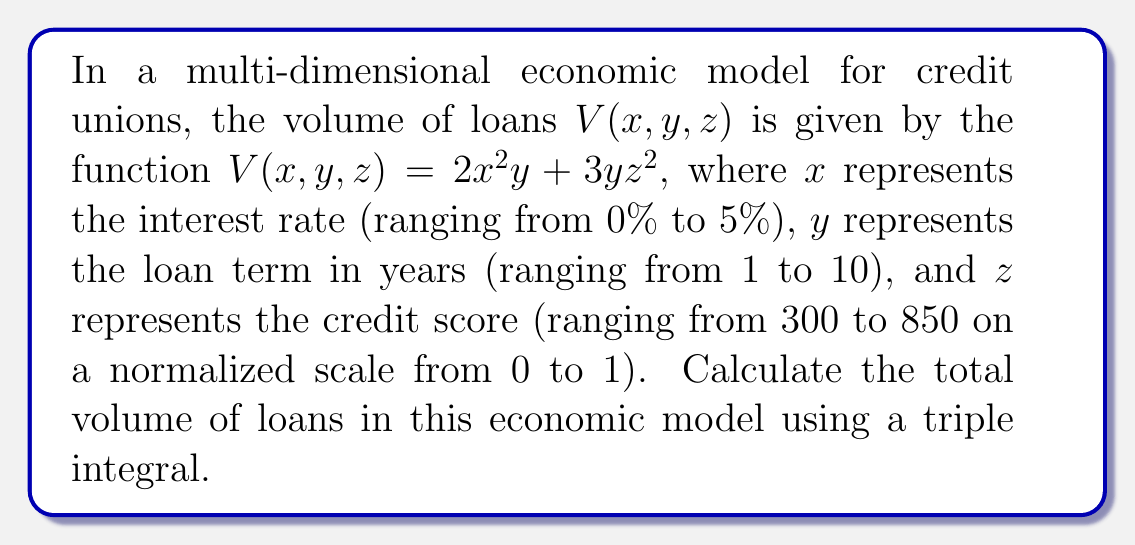Could you help me with this problem? To solve this problem, we need to set up and evaluate a triple integral over the given ranges for each variable. Let's approach this step-by-step:

1) The volume function is $V(x,y,z) = 2x^2y + 3yz^2$

2) The limits of integration are:
   $x$: 0 to 0.05 (converting 5% to decimal)
   $y$: 1 to 10
   $z$: 0 to 1 (normalized credit score)

3) Set up the triple integral:

   $$\iiint_V V(x,y,z) \, dz \, dy \, dx = \int_0^{0.05} \int_1^{10} \int_0^1 (2x^2y + 3yz^2) \, dz \, dy \, dx$$

4) Evaluate the inner integral with respect to $z$:

   $$\int_0^{0.05} \int_1^{10} \left[2x^2yz + yz^3\right]_0^1 \, dy \, dx$$
   $$= \int_0^{0.05} \int_1^{10} (2x^2y + y) \, dy \, dx$$

5) Evaluate the integral with respect to $y$:

   $$\int_0^{0.05} \left[x^2y^2 + \frac{1}{2}y^2\right]_1^{10} \, dx$$
   $$= \int_0^{0.05} (100x^2 + 50 - x^2 - \frac{1}{2}) \, dx$$
   $$= \int_0^{0.05} (99x^2 + 49.5) \, dx$$

6) Evaluate the final integral with respect to $x$:

   $$\left[33x^3 + 49.5x\right]_0^{0.05}$$
   $$= (33(0.05)^3 + 49.5(0.05)) - (0)$$
   $$= 0.004125 + 2.475 = 2.479125$$

Therefore, the total volume of loans in this economic model is approximately 2.479125 units.
Answer: 2.479125 units 